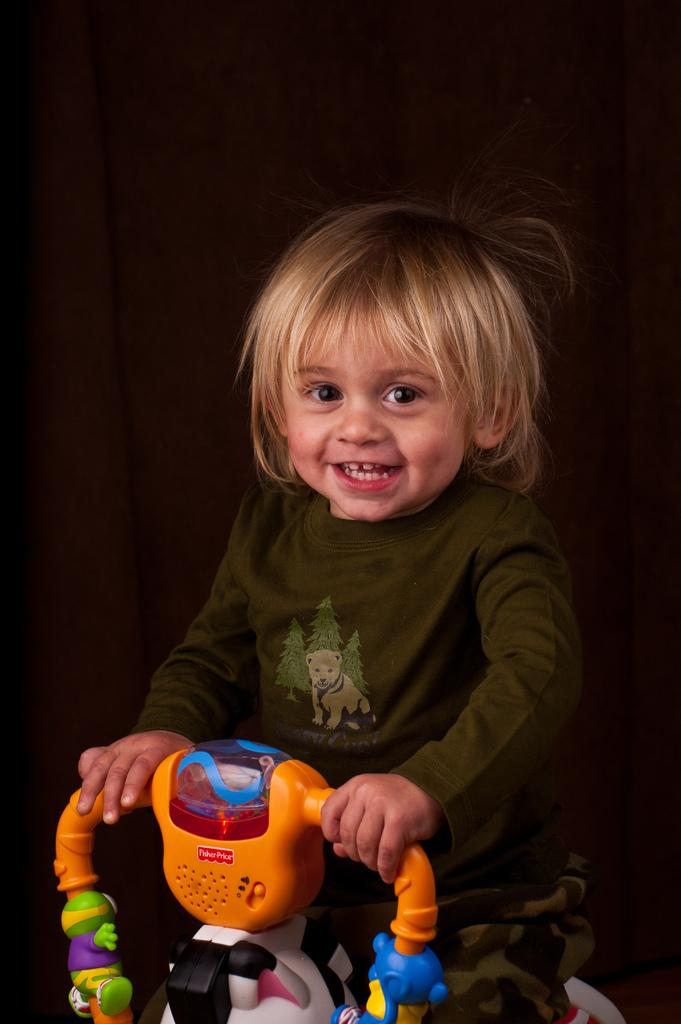What is the main subject of the image? The main subject of the image is a kid. What is the kid doing in the image? The kid is sitting on a grow ride and smiling. What can be seen in the background of the image? There is a wall in the background of the image. What type of appliance is the kid using to smash objects in the image? There is no appliance or object smashing in the image; the kid is simply sitting on a grow ride and smiling. 